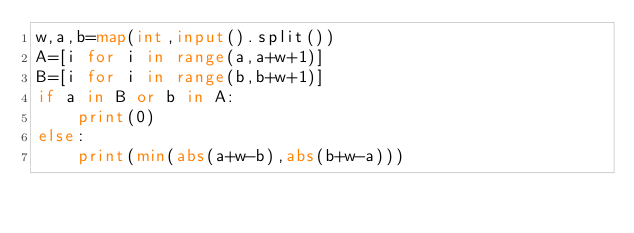<code> <loc_0><loc_0><loc_500><loc_500><_Python_>w,a,b=map(int,input().split())
A=[i for i in range(a,a+w+1)]
B=[i for i in range(b,b+w+1)]
if a in B or b in A:
    print(0)
else:
    print(min(abs(a+w-b),abs(b+w-a)))</code> 